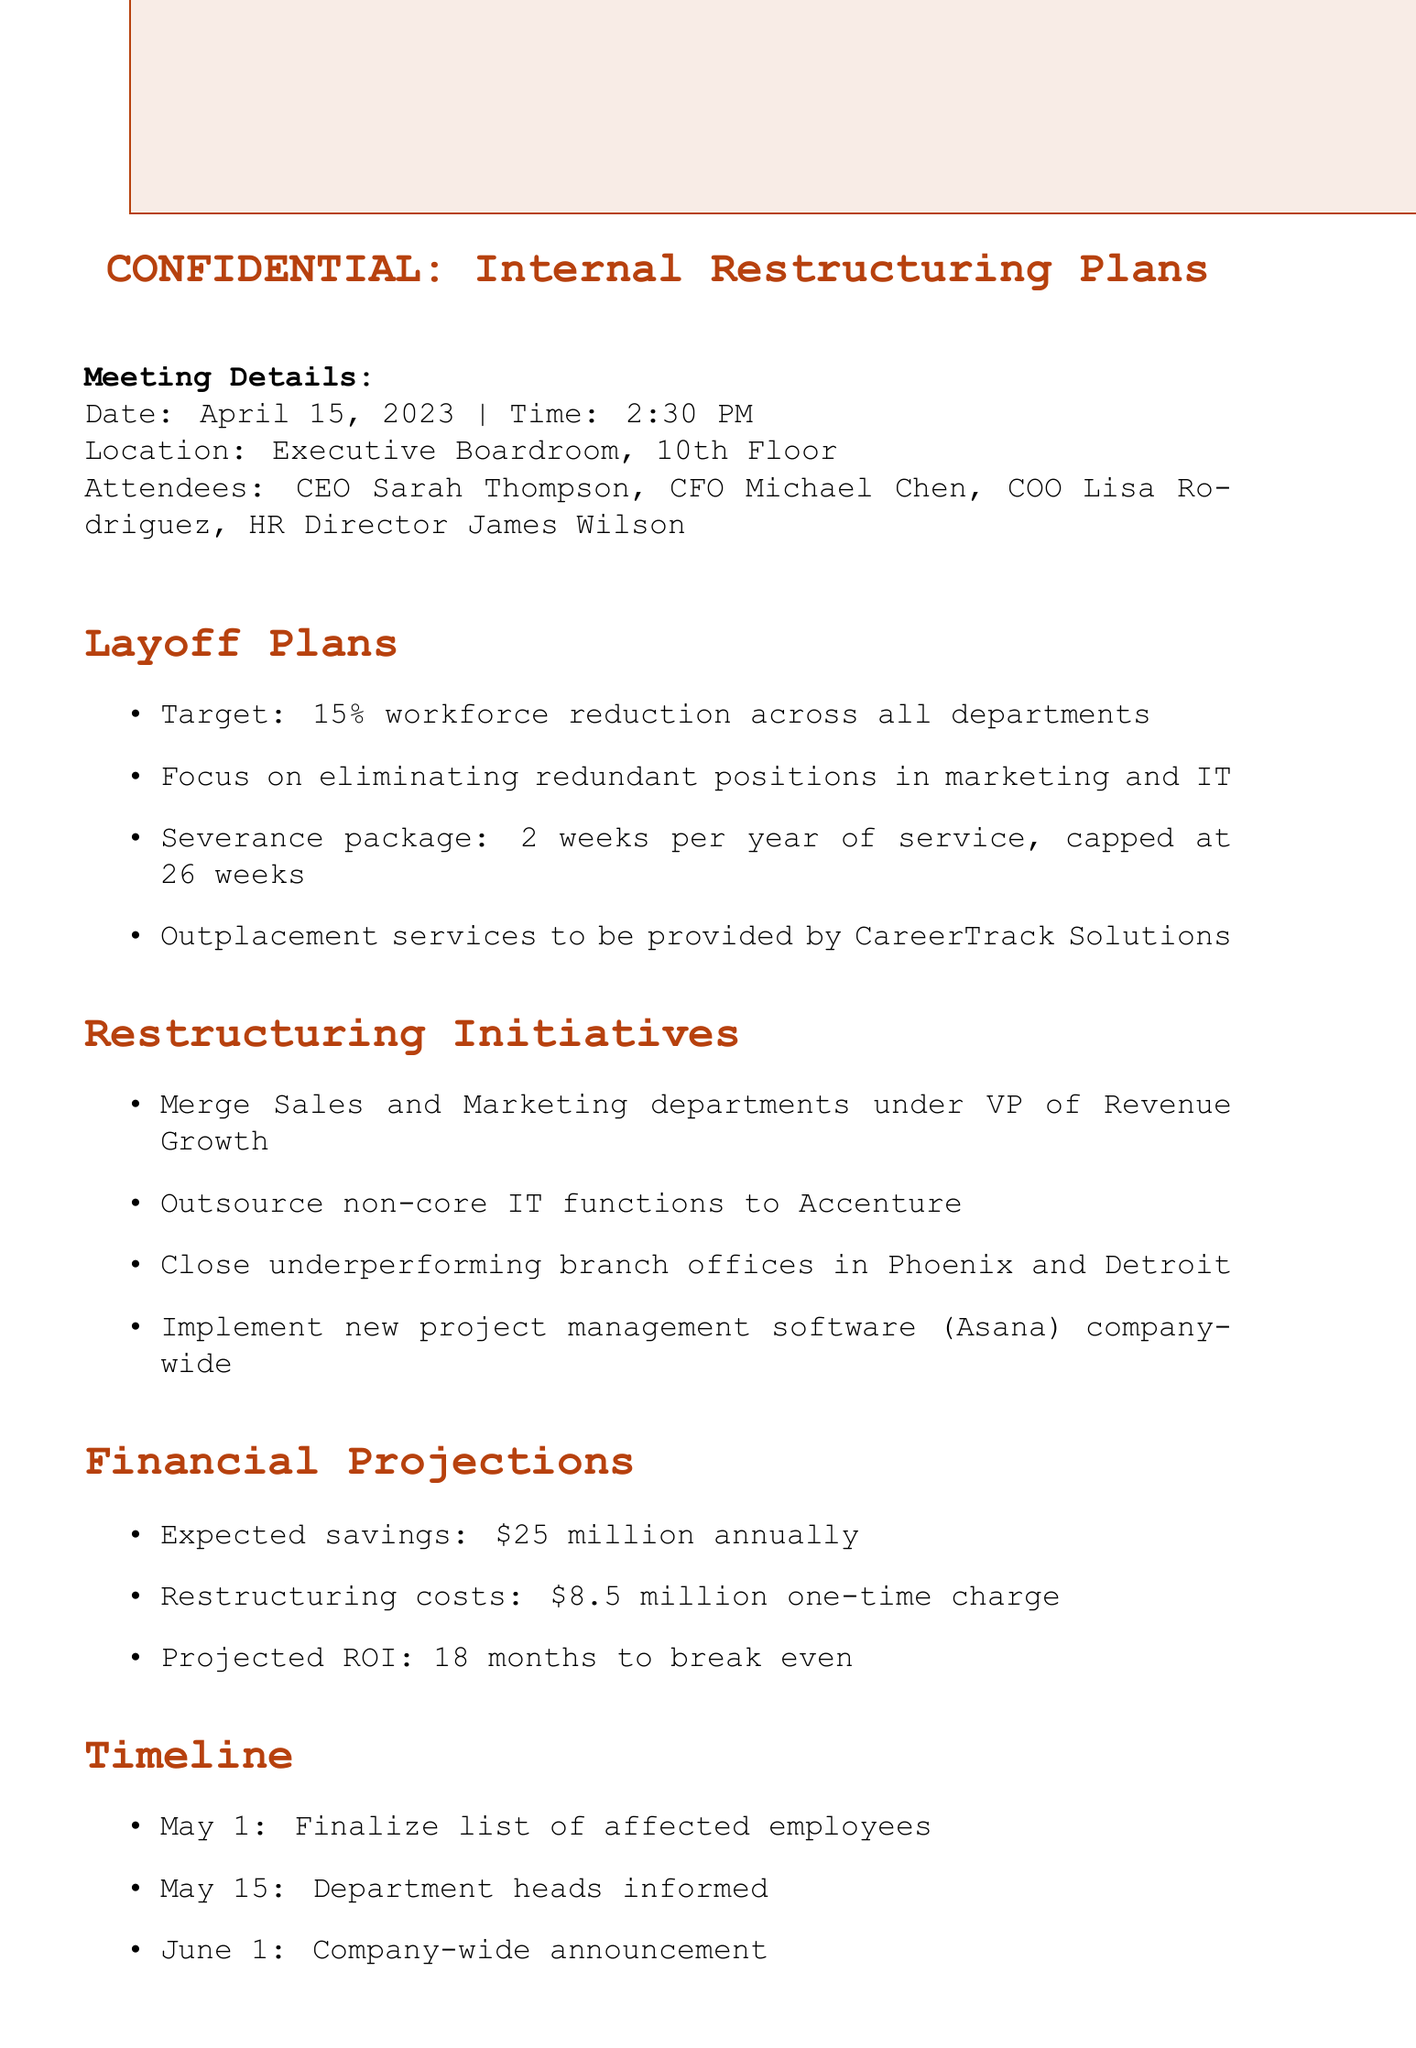What is the date of the meeting? The date of the meeting is explicitly stated in the document as April 15, 2023.
Answer: April 15, 2023 Who is the CEO? The document lists the attendees, and Sarah Thompson is identified as the CEO.
Answer: Sarah Thompson What is the target percentage for workforce reduction? The document specifies that the target workforce reduction is 15%.
Answer: 15% What will be the severance package for affected employees? The document states the severance package includes 2 weeks per year of service, capped at 26 weeks.
Answer: 2 weeks per year of service, capped at 26 weeks How much is expected in annual savings? According to the financial projections, the expected savings are $25 million annually.
Answer: $25 million annually Which two branch offices are to be closed? The document mentions closure of underperforming branch offices in Phoenix and Detroit.
Answer: Phoenix and Detroit What is the one-time charge for restructuring costs? The restructuring costs are listed as an $8.5 million one-time charge.
Answer: $8.5 million When is the company-wide announcement scheduled? The timeline indicates that the company-wide announcement is set for June 1.
Answer: June 1 What consulting firm will provide outplacement services? The document notes that CareerTrack Solutions will provide outplacement services.
Answer: CareerTrack Solutions 